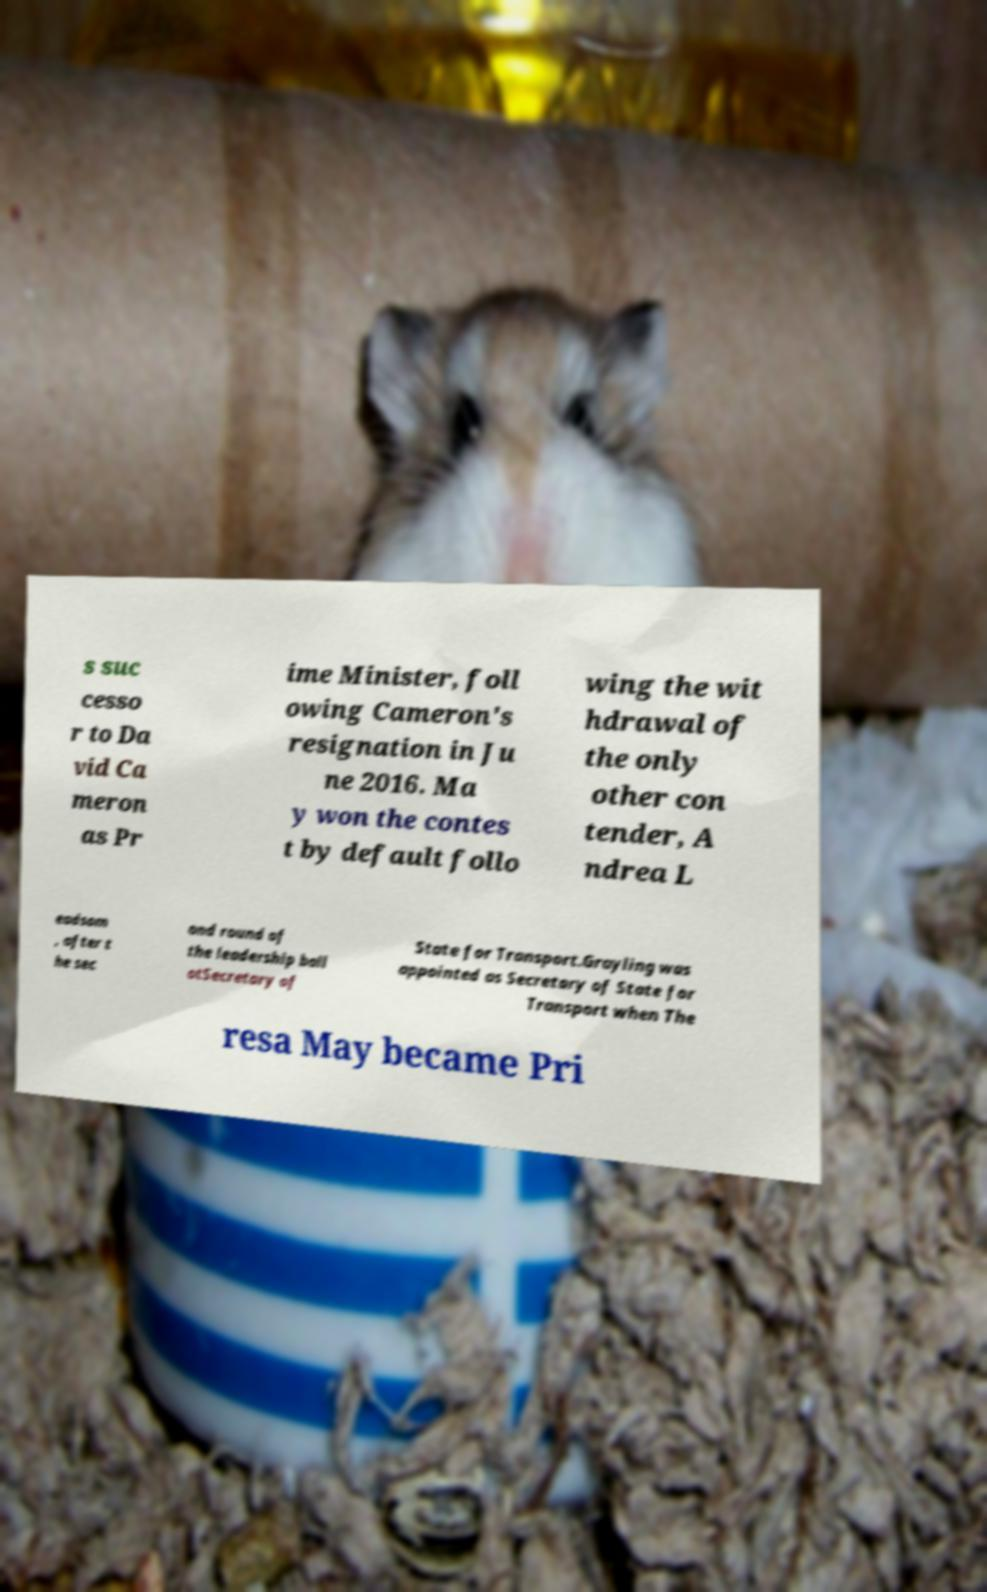Can you accurately transcribe the text from the provided image for me? s suc cesso r to Da vid Ca meron as Pr ime Minister, foll owing Cameron's resignation in Ju ne 2016. Ma y won the contes t by default follo wing the wit hdrawal of the only other con tender, A ndrea L eadsom , after t he sec ond round of the leadership ball otSecretary of State for Transport.Grayling was appointed as Secretary of State for Transport when The resa May became Pri 